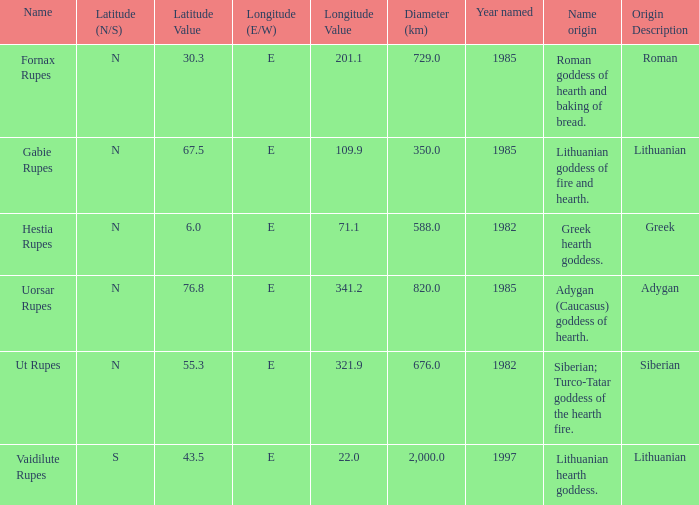9e, how many elements were identified? 1.0. 